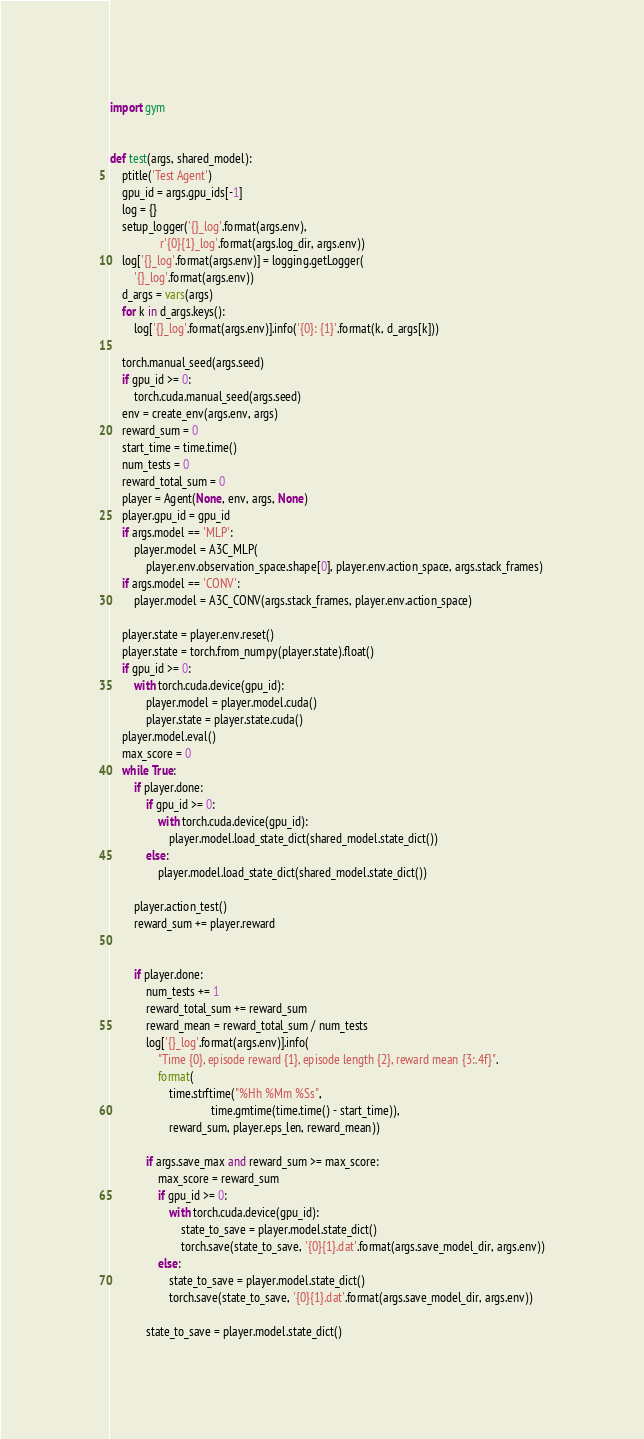Convert code to text. <code><loc_0><loc_0><loc_500><loc_500><_Python_>import gym


def test(args, shared_model):
    ptitle('Test Agent')
    gpu_id = args.gpu_ids[-1]
    log = {}
    setup_logger('{}_log'.format(args.env),
                 r'{0}{1}_log'.format(args.log_dir, args.env))
    log['{}_log'.format(args.env)] = logging.getLogger(
        '{}_log'.format(args.env))
    d_args = vars(args)
    for k in d_args.keys():
        log['{}_log'.format(args.env)].info('{0}: {1}'.format(k, d_args[k]))

    torch.manual_seed(args.seed)
    if gpu_id >= 0:
        torch.cuda.manual_seed(args.seed)
    env = create_env(args.env, args)
    reward_sum = 0
    start_time = time.time()
    num_tests = 0
    reward_total_sum = 0
    player = Agent(None, env, args, None)
    player.gpu_id = gpu_id
    if args.model == 'MLP':
        player.model = A3C_MLP(
            player.env.observation_space.shape[0], player.env.action_space, args.stack_frames)
    if args.model == 'CONV':
        player.model = A3C_CONV(args.stack_frames, player.env.action_space)

    player.state = player.env.reset()
    player.state = torch.from_numpy(player.state).float()
    if gpu_id >= 0:
        with torch.cuda.device(gpu_id):
            player.model = player.model.cuda()
            player.state = player.state.cuda()
    player.model.eval()
    max_score = 0
    while True:
        if player.done:
            if gpu_id >= 0:
                with torch.cuda.device(gpu_id):
                    player.model.load_state_dict(shared_model.state_dict())
            else:
                player.model.load_state_dict(shared_model.state_dict())

        player.action_test()
        reward_sum += player.reward
        

        if player.done:
            num_tests += 1
            reward_total_sum += reward_sum
            reward_mean = reward_total_sum / num_tests
            log['{}_log'.format(args.env)].info(
                "Time {0}, episode reward {1}, episode length {2}, reward mean {3:.4f}".
                format(
                    time.strftime("%Hh %Mm %Ss",
                                  time.gmtime(time.time() - start_time)),
                    reward_sum, player.eps_len, reward_mean))

            if args.save_max and reward_sum >= max_score:
                max_score = reward_sum
                if gpu_id >= 0:
                    with torch.cuda.device(gpu_id):
                        state_to_save = player.model.state_dict()
                        torch.save(state_to_save, '{0}{1}.dat'.format(args.save_model_dir, args.env))
                else:
                    state_to_save = player.model.state_dict()
                    torch.save(state_to_save, '{0}{1}.dat'.format(args.save_model_dir, args.env))

            state_to_save = player.model.state_dict()</code> 